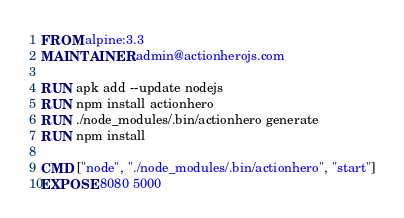<code> <loc_0><loc_0><loc_500><loc_500><_Dockerfile_>FROM alpine:3.3
MAINTAINER admin@actionherojs.com

RUN apk add --update nodejs
RUN npm install actionhero
RUN ./node_modules/.bin/actionhero generate
RUN npm install

CMD ["node", "./node_modules/.bin/actionhero", "start"]
EXPOSE 8080 5000
</code> 